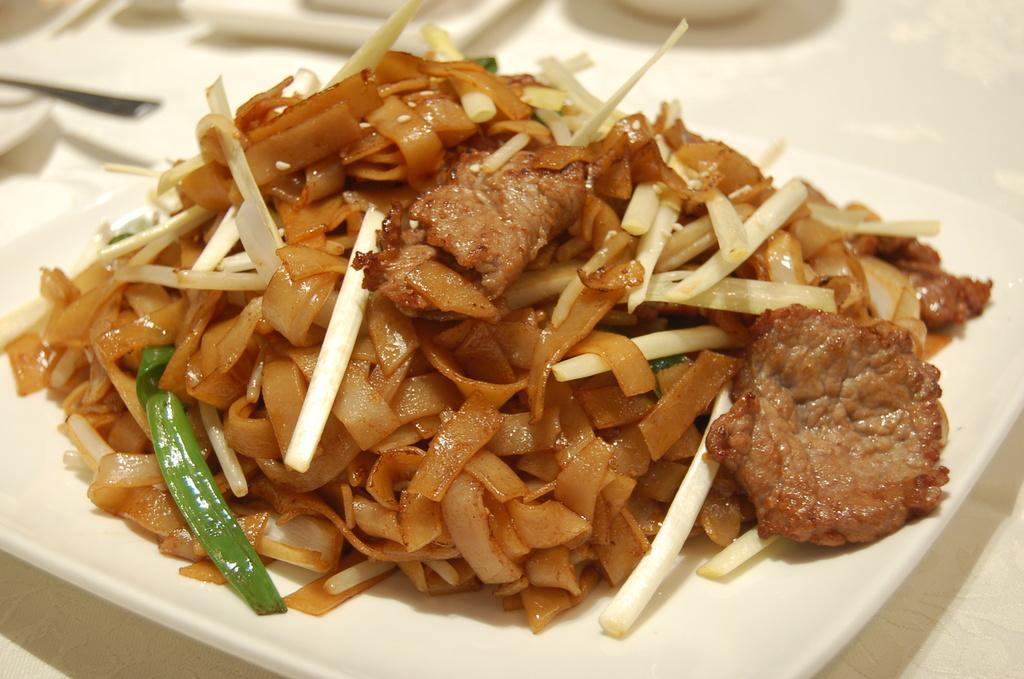What is on the plate that is visible in the image? There is a plate with food in the image. What else can be seen on the table in the image? There are objects on a table in the image. Can you see a snail crawling on the food in the image? No, there is no snail present in the image. 